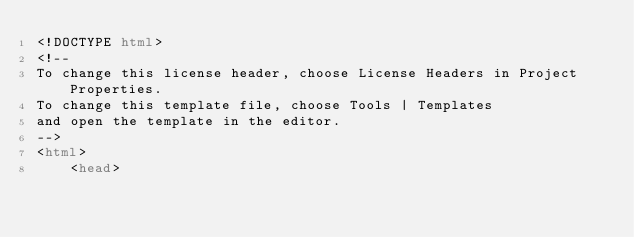<code> <loc_0><loc_0><loc_500><loc_500><_HTML_><!DOCTYPE html>
<!--
To change this license header, choose License Headers in Project Properties.
To change this template file, choose Tools | Templates
and open the template in the editor.
-->
<html>
    <head></code> 